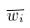<formula> <loc_0><loc_0><loc_500><loc_500>\overline { w _ { i } }</formula> 